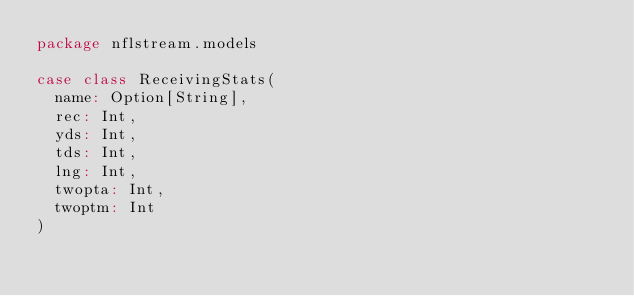Convert code to text. <code><loc_0><loc_0><loc_500><loc_500><_Scala_>package nflstream.models

case class ReceivingStats(
  name: Option[String],
  rec: Int,
  yds: Int,
  tds: Int,
  lng: Int,
  twopta: Int,
  twoptm: Int
)
</code> 